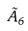<formula> <loc_0><loc_0><loc_500><loc_500>\tilde { A } _ { 6 }</formula> 